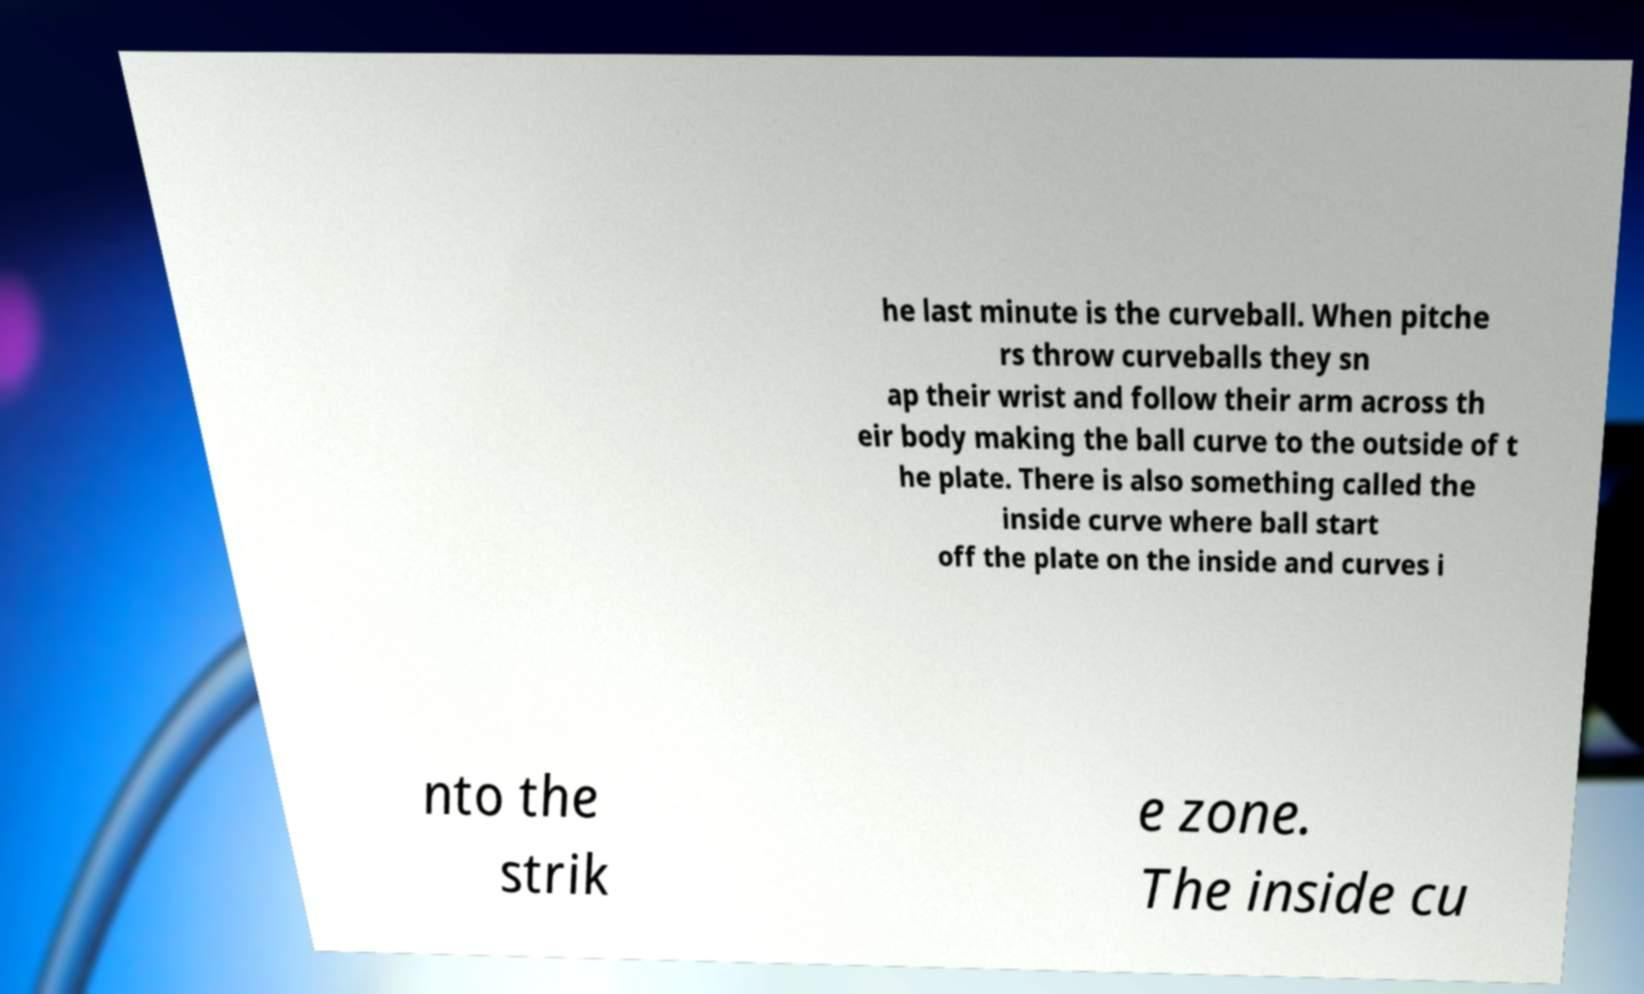Please read and relay the text visible in this image. What does it say? he last minute is the curveball. When pitche rs throw curveballs they sn ap their wrist and follow their arm across th eir body making the ball curve to the outside of t he plate. There is also something called the inside curve where ball start off the plate on the inside and curves i nto the strik e zone. The inside cu 